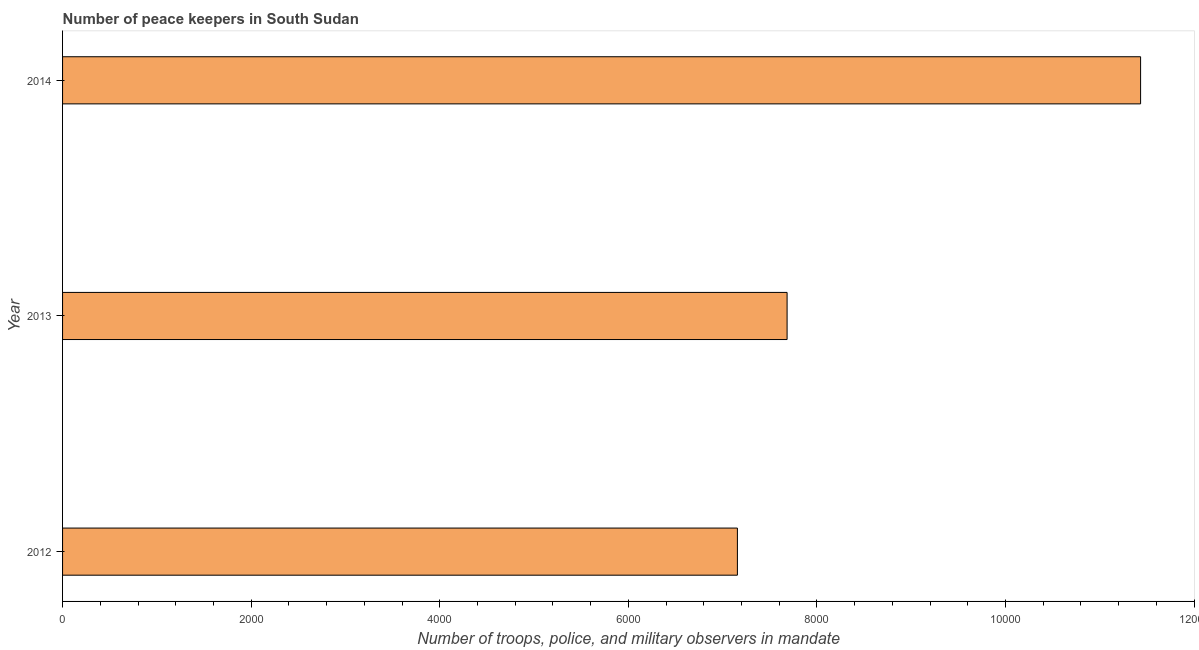What is the title of the graph?
Keep it short and to the point. Number of peace keepers in South Sudan. What is the label or title of the X-axis?
Offer a very short reply. Number of troops, police, and military observers in mandate. What is the label or title of the Y-axis?
Provide a succinct answer. Year. What is the number of peace keepers in 2012?
Ensure brevity in your answer.  7157. Across all years, what is the maximum number of peace keepers?
Your response must be concise. 1.14e+04. Across all years, what is the minimum number of peace keepers?
Provide a succinct answer. 7157. In which year was the number of peace keepers maximum?
Ensure brevity in your answer.  2014. What is the sum of the number of peace keepers?
Provide a succinct answer. 2.63e+04. What is the difference between the number of peace keepers in 2012 and 2013?
Provide a succinct answer. -527. What is the average number of peace keepers per year?
Provide a succinct answer. 8758. What is the median number of peace keepers?
Make the answer very short. 7684. In how many years, is the number of peace keepers greater than 1200 ?
Provide a succinct answer. 3. Do a majority of the years between 2013 and 2012 (inclusive) have number of peace keepers greater than 2800 ?
Offer a terse response. No. What is the ratio of the number of peace keepers in 2013 to that in 2014?
Make the answer very short. 0.67. Is the number of peace keepers in 2012 less than that in 2013?
Make the answer very short. Yes. Is the difference between the number of peace keepers in 2013 and 2014 greater than the difference between any two years?
Your response must be concise. No. What is the difference between the highest and the second highest number of peace keepers?
Make the answer very short. 3749. What is the difference between the highest and the lowest number of peace keepers?
Offer a terse response. 4276. In how many years, is the number of peace keepers greater than the average number of peace keepers taken over all years?
Make the answer very short. 1. Are the values on the major ticks of X-axis written in scientific E-notation?
Offer a terse response. No. What is the Number of troops, police, and military observers in mandate of 2012?
Offer a very short reply. 7157. What is the Number of troops, police, and military observers in mandate of 2013?
Keep it short and to the point. 7684. What is the Number of troops, police, and military observers in mandate in 2014?
Provide a succinct answer. 1.14e+04. What is the difference between the Number of troops, police, and military observers in mandate in 2012 and 2013?
Provide a succinct answer. -527. What is the difference between the Number of troops, police, and military observers in mandate in 2012 and 2014?
Offer a very short reply. -4276. What is the difference between the Number of troops, police, and military observers in mandate in 2013 and 2014?
Offer a terse response. -3749. What is the ratio of the Number of troops, police, and military observers in mandate in 2012 to that in 2013?
Keep it short and to the point. 0.93. What is the ratio of the Number of troops, police, and military observers in mandate in 2012 to that in 2014?
Keep it short and to the point. 0.63. What is the ratio of the Number of troops, police, and military observers in mandate in 2013 to that in 2014?
Ensure brevity in your answer.  0.67. 